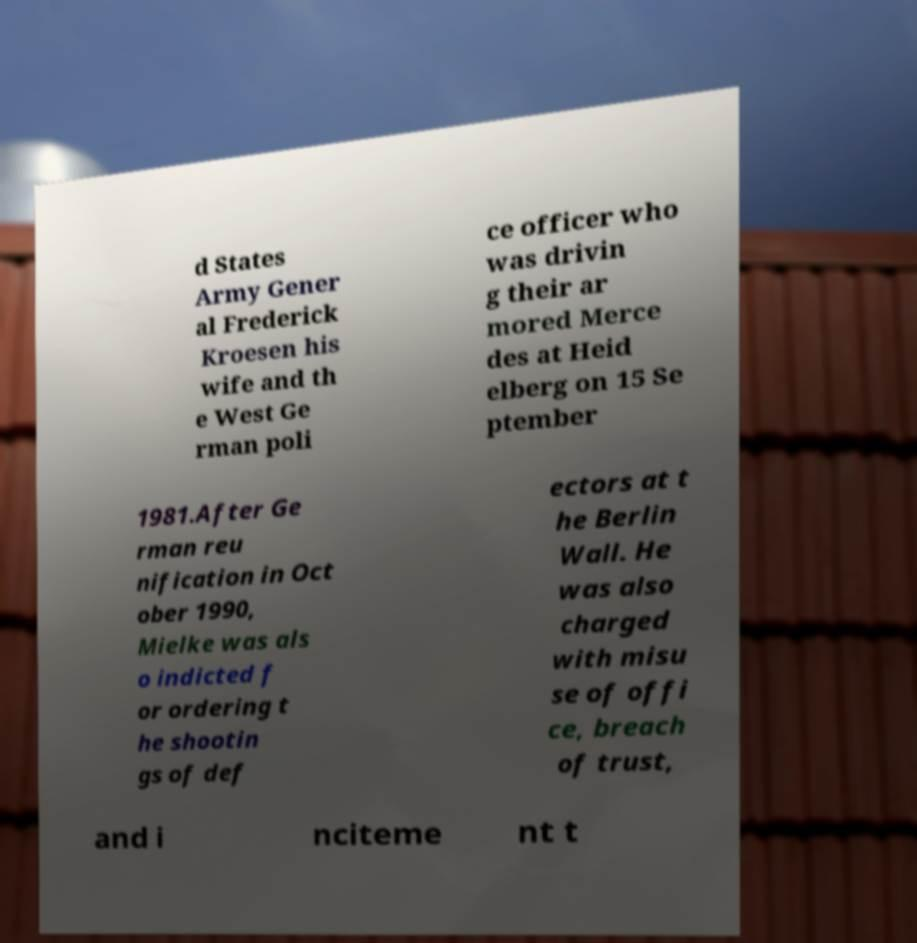Can you accurately transcribe the text from the provided image for me? d States Army Gener al Frederick Kroesen his wife and th e West Ge rman poli ce officer who was drivin g their ar mored Merce des at Heid elberg on 15 Se ptember 1981.After Ge rman reu nification in Oct ober 1990, Mielke was als o indicted f or ordering t he shootin gs of def ectors at t he Berlin Wall. He was also charged with misu se of offi ce, breach of trust, and i nciteme nt t 